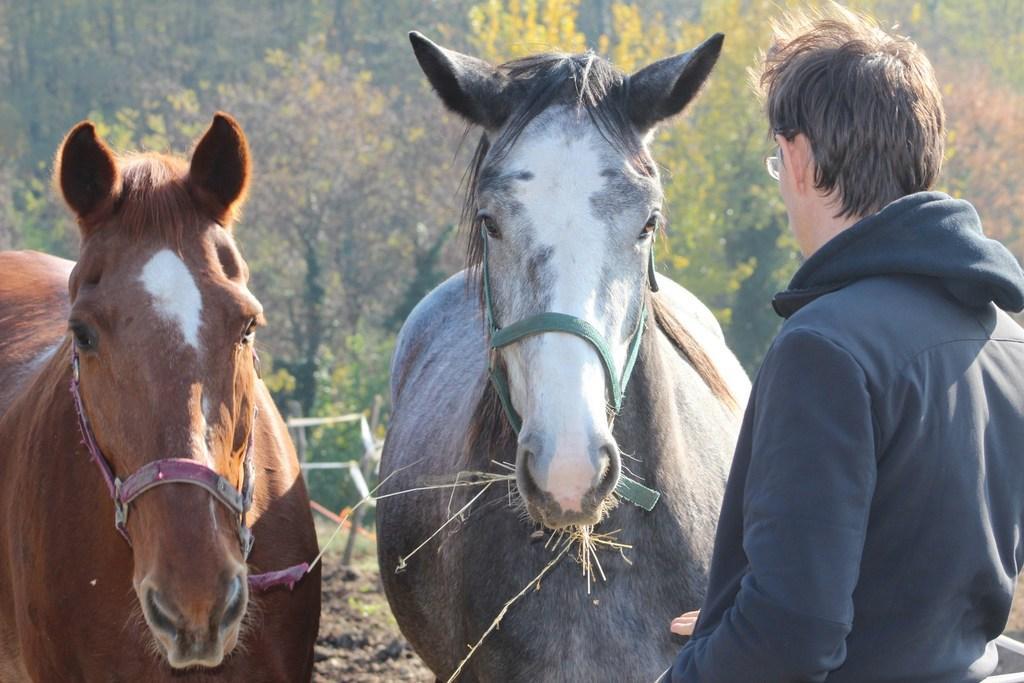Can you describe this image briefly? Here we can see two horses and a man on the right side. In the background we can see trees. 